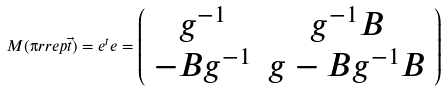<formula> <loc_0><loc_0><loc_500><loc_500>M ( \i r r e p { \vec { t } } ) = e ^ { t } e = \left ( \begin{array} { c c } g ^ { - 1 } & g ^ { - 1 } B \\ - B g ^ { - 1 } & g - B g ^ { - 1 } B \\ \end{array} \right )</formula> 